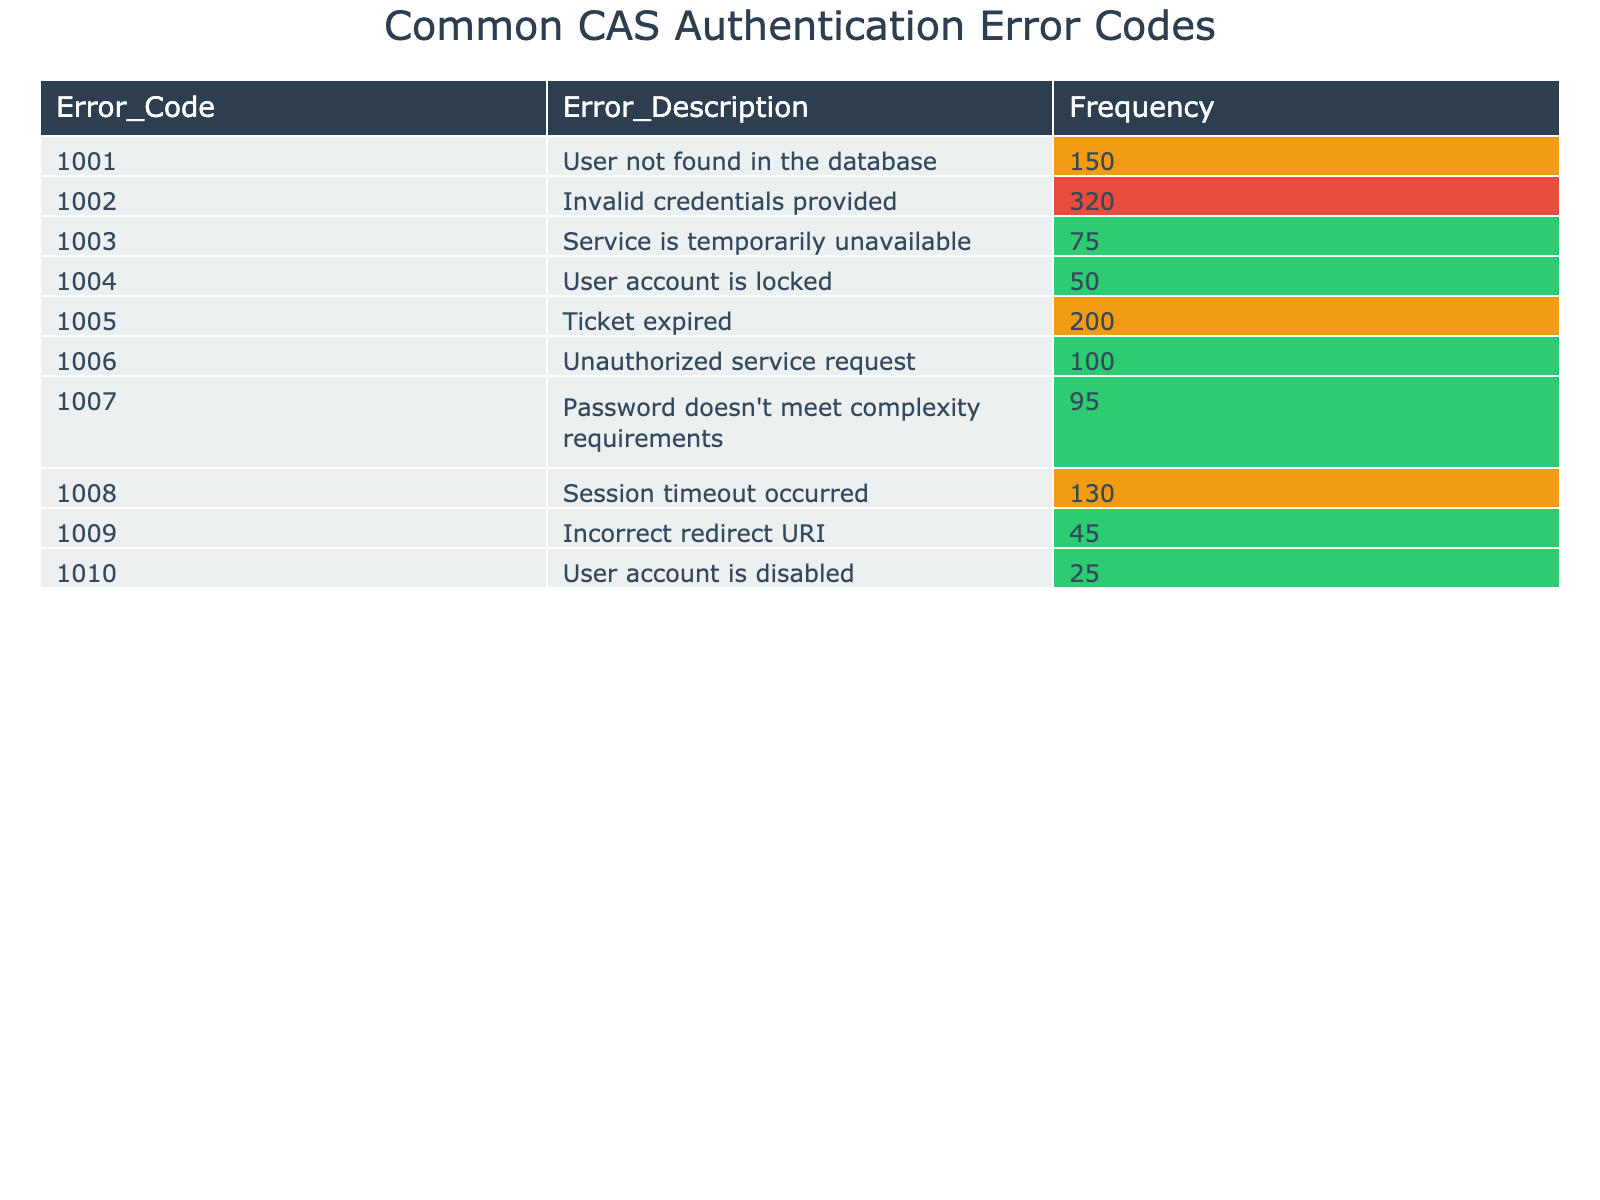What is the error code for "User account is locked"? From the table, looking for the row that has the description "User account is locked." The error code associated with this description is 1004.
Answer: 1004 What is the frequency of the error "Invalid credentials provided"? The table shows that the frequency for the error description "Invalid credentials provided" is listed under the corresponding row, which is 320.
Answer: 320 Which error has the lowest frequency? By examining the frequencies in the table, the error with the lowest frequency is "User account is disabled," which has a frequency of 25.
Answer: 25 How many errors have a frequency greater than 100? To find this, count the errors in the table that show a frequency greater than 100. There are four such errors: Invalid credentials (320), Ticket expired (200), Session timeout (130), and Unauthorized service request (100). Therefore, the total count is 4.
Answer: 4 Is there an error code for "Session timeout occurred"? The table needs to be checked for the description "Session timeout occurred." It does exist, and its corresponding error code is 1008.
Answer: Yes What is the average frequency of all errors? First, sum all the frequencies: 150 + 320 + 75 + 50 + 200 + 100 + 95 + 130 + 45 + 25 = 1,190. There are 10 errors in total. Then, calculate the average: 1,190 / 10 = 119.
Answer: 119 Which error has a frequency between 50 and 100? Review the frequency values in the table to find errors that fall between 50 and 100. You find that four errors fit this criterion: "User account is locked" (50), "Unauthorized service request" (100), "Password doesn't meet complexity requirements" (95), and "Session timeout occurred" (130 is excluded).
Answer: 3 What is the sum of frequencies for errors regarding user accounts (locked, disabled, and not found)? The relevant frequencies are for "User account is locked" (50), "User account is disabled" (25), and "User not found in the database" (150). Adding these gives: 50 + 25 + 150 = 225.
Answer: 225 What percentage of errors are due to invalid credentials? The frequency for invalid credentials is 320. To find the percentage, divide 320 by the total frequency of 1,190 and multiply by 100: (320 / 1190) * 100 ≈ 26.89%.
Answer: 26.89% How many total errors are represented in the table? Simply count the total number of rows in the table, which reflects the number of different errors listed. There are 10 specific error codes.
Answer: 10 